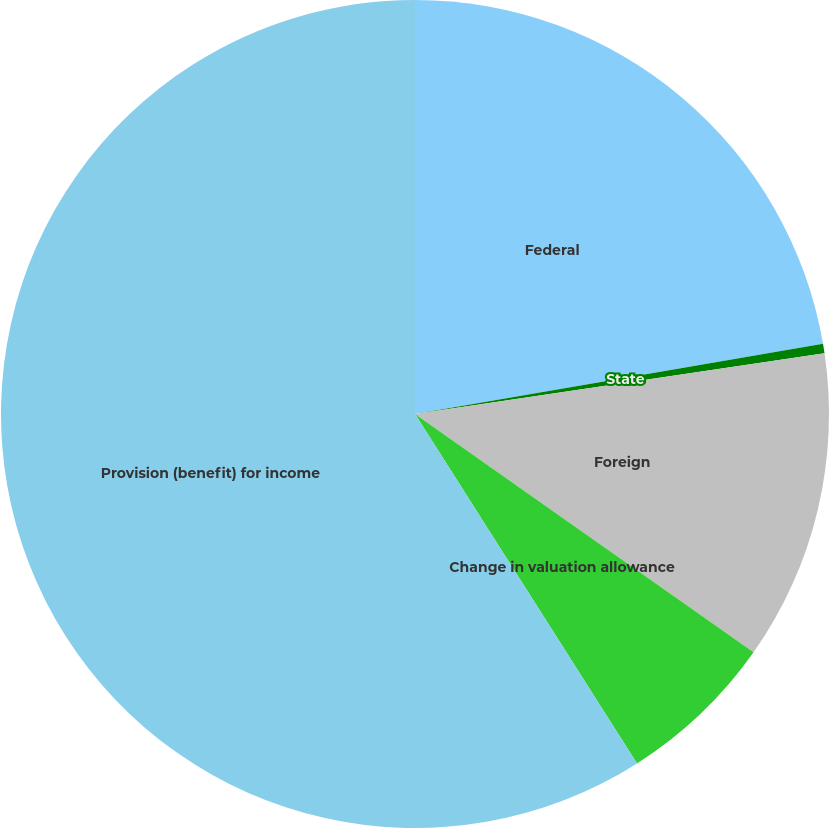Convert chart. <chart><loc_0><loc_0><loc_500><loc_500><pie_chart><fcel>Federal<fcel>State<fcel>Foreign<fcel>Change in valuation allowance<fcel>Provision (benefit) for income<nl><fcel>22.29%<fcel>0.37%<fcel>12.1%<fcel>6.23%<fcel>59.01%<nl></chart> 